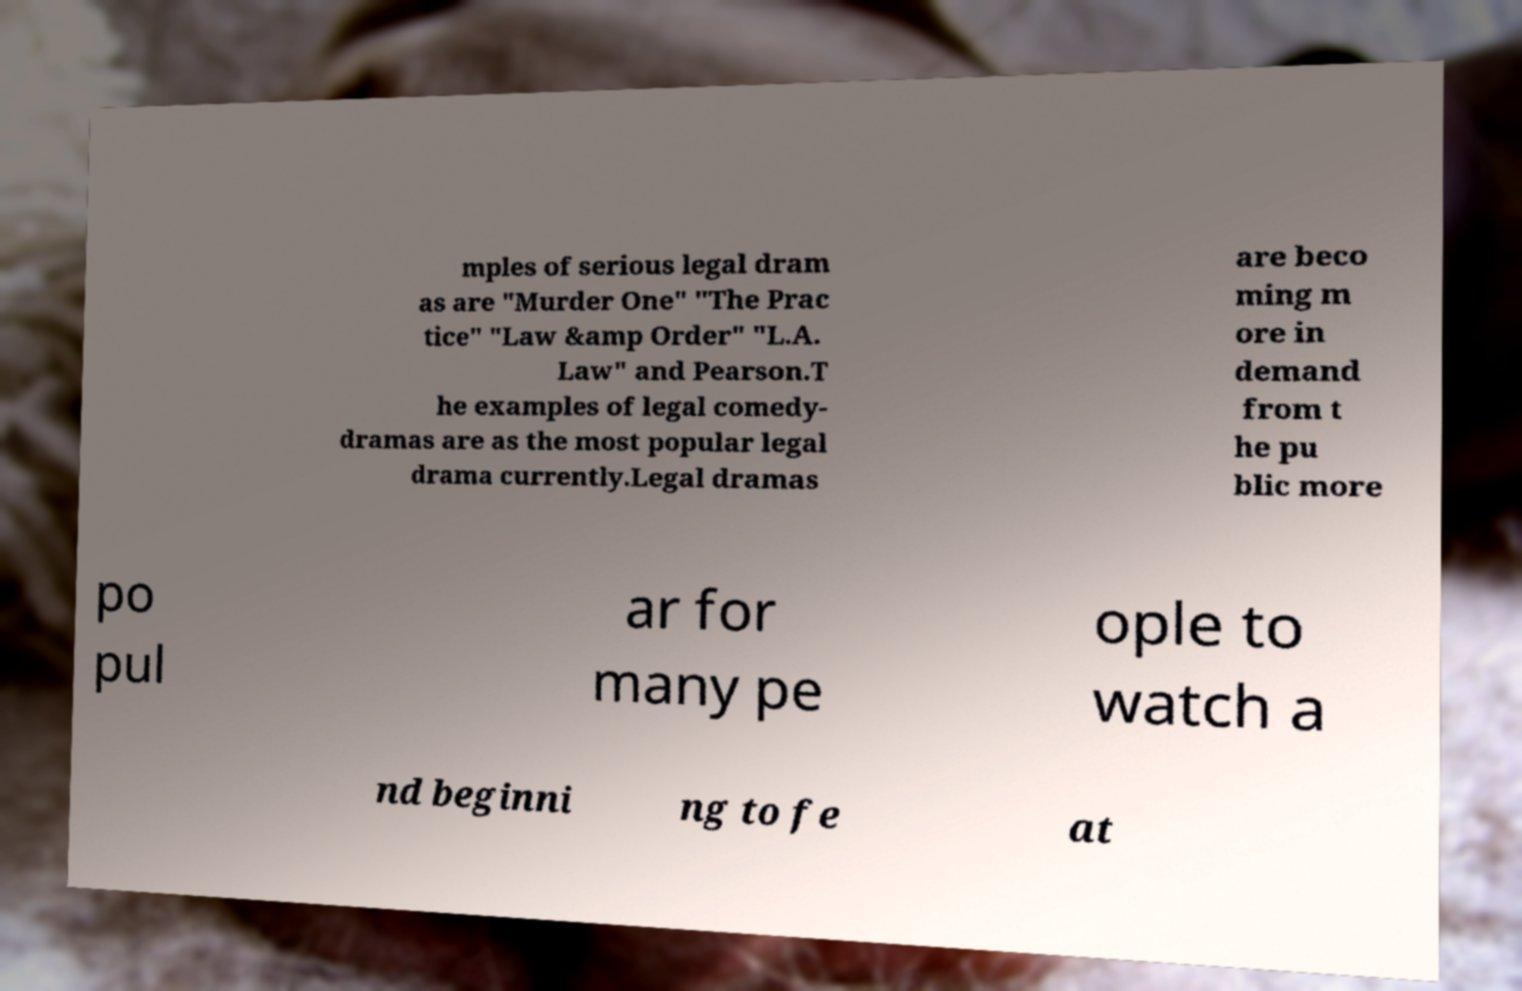Please read and relay the text visible in this image. What does it say? mples of serious legal dram as are "Murder One" "The Prac tice" "Law &amp Order" "L.A. Law" and Pearson.T he examples of legal comedy- dramas are as the most popular legal drama currently.Legal dramas are beco ming m ore in demand from t he pu blic more po pul ar for many pe ople to watch a nd beginni ng to fe at 